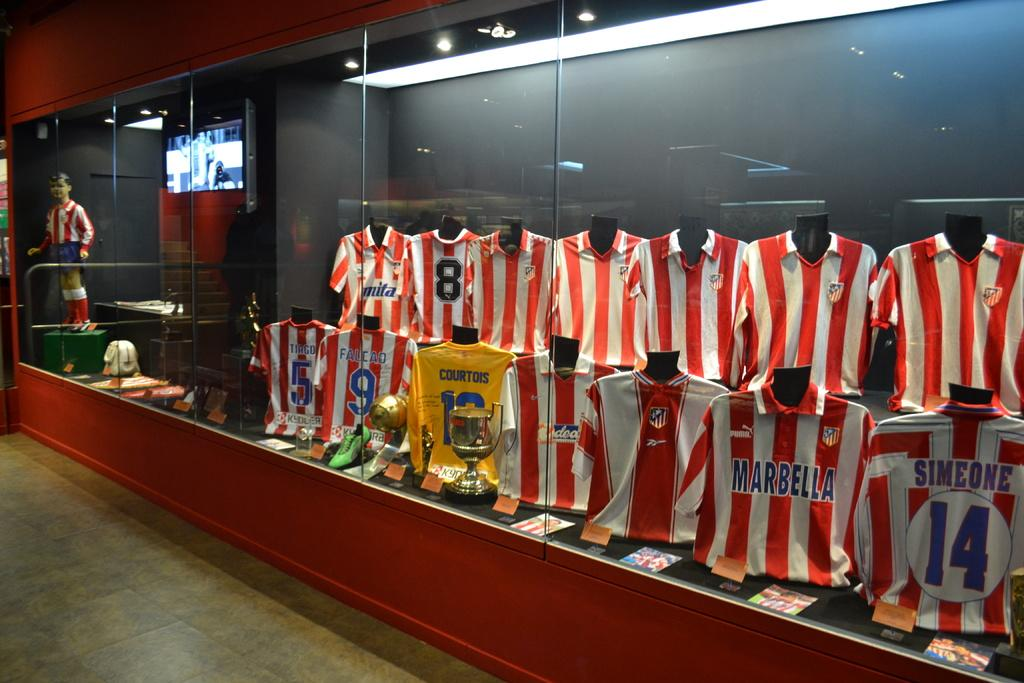Provide a one-sentence caption for the provided image. The display of red and white striped jerseys includes Tiago's and Falcao's. 